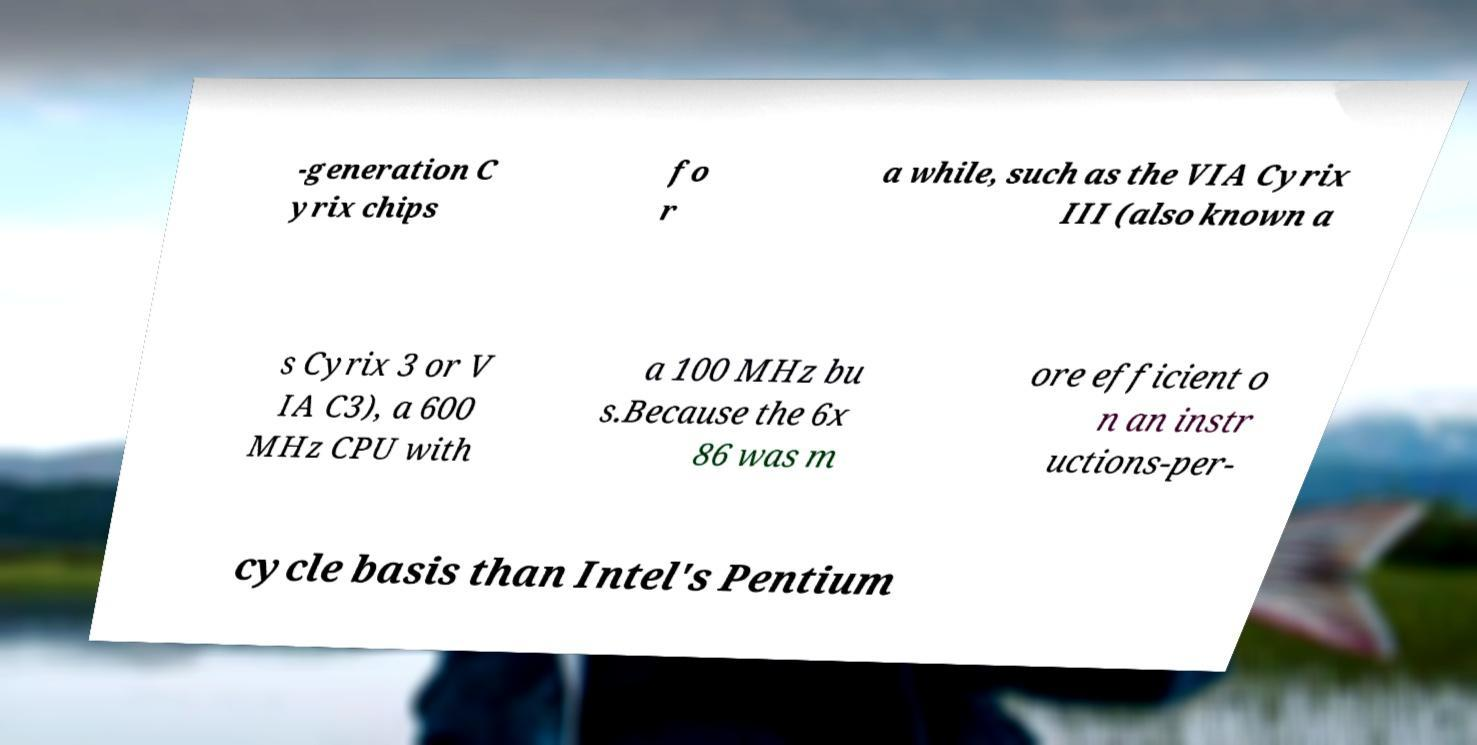Please read and relay the text visible in this image. What does it say? -generation C yrix chips fo r a while, such as the VIA Cyrix III (also known a s Cyrix 3 or V IA C3), a 600 MHz CPU with a 100 MHz bu s.Because the 6x 86 was m ore efficient o n an instr uctions-per- cycle basis than Intel's Pentium 